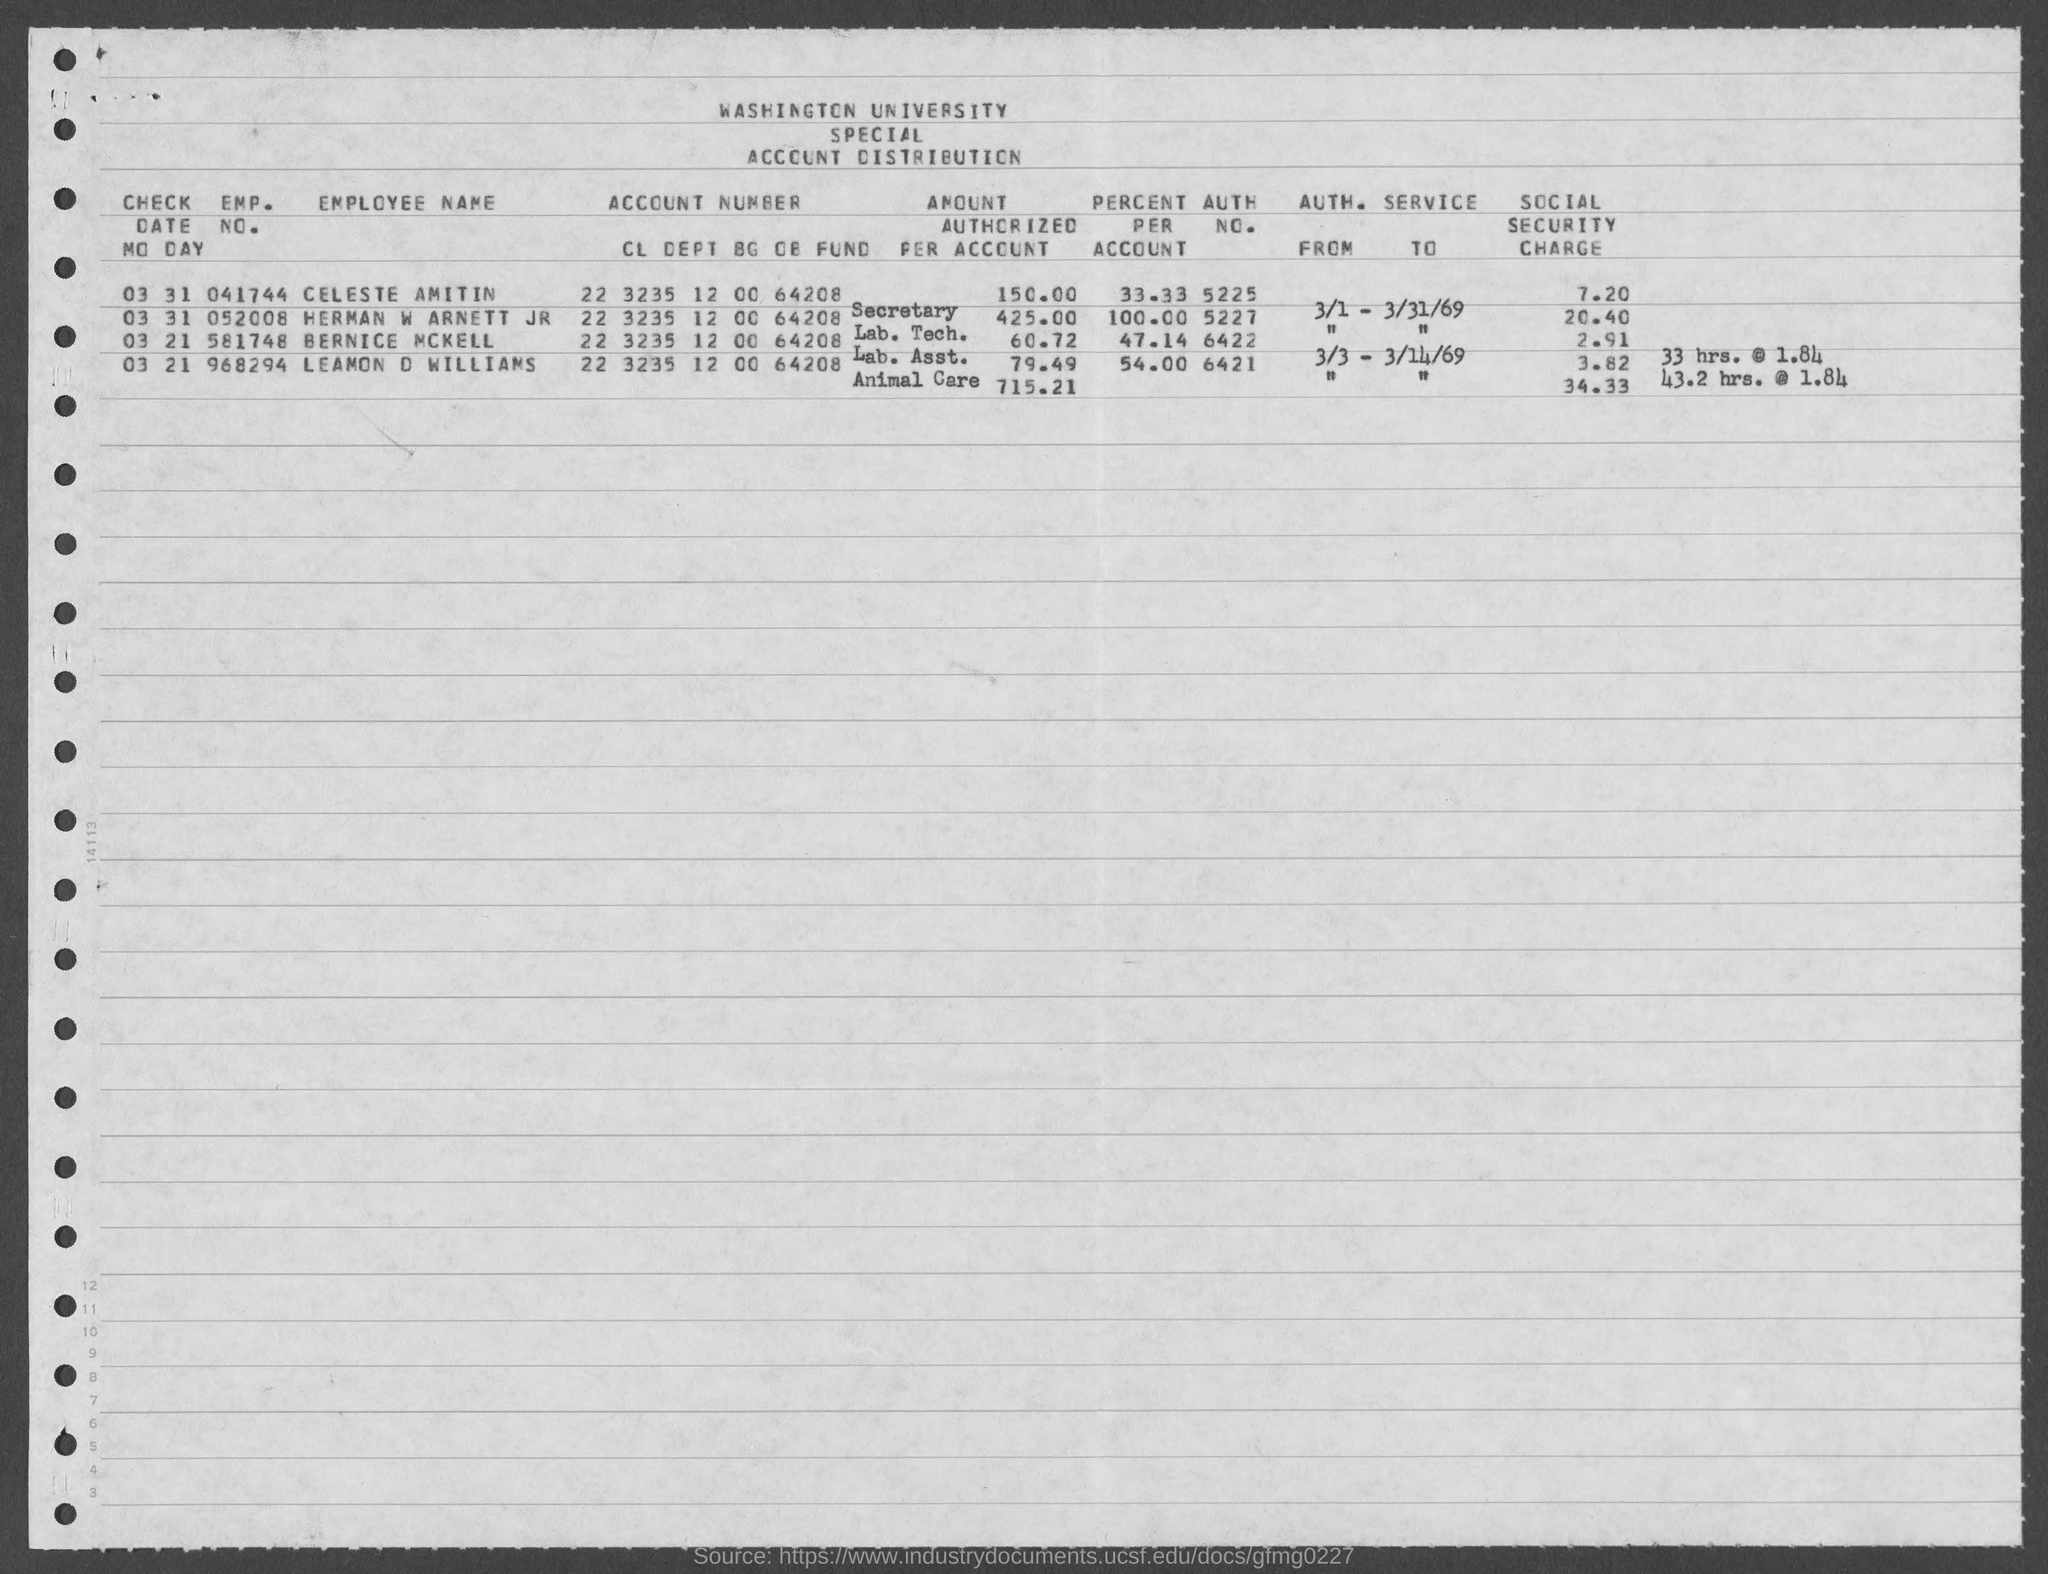Give some essential details in this illustration. The authorization number of Herman W Arnett Jr is 5227. The author's name is Leamon D Williams, and his authorization number is 6421. What is the authorization number of Bernice McKell? It is 6422... The employee number of Bernice McKell is 581748. Herman W Arnett Jr's employment number is 052008. 